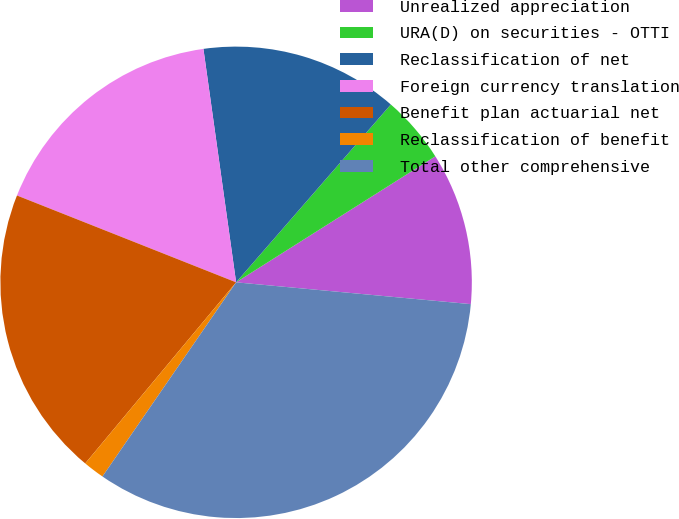Convert chart to OTSL. <chart><loc_0><loc_0><loc_500><loc_500><pie_chart><fcel>Unrealized appreciation<fcel>URA(D) on securities - OTTI<fcel>Reclassification of net<fcel>Foreign currency translation<fcel>Benefit plan actuarial net<fcel>Reclassification of benefit<fcel>Total other comprehensive<nl><fcel>10.45%<fcel>4.63%<fcel>13.61%<fcel>16.78%<fcel>19.95%<fcel>1.46%<fcel>33.12%<nl></chart> 